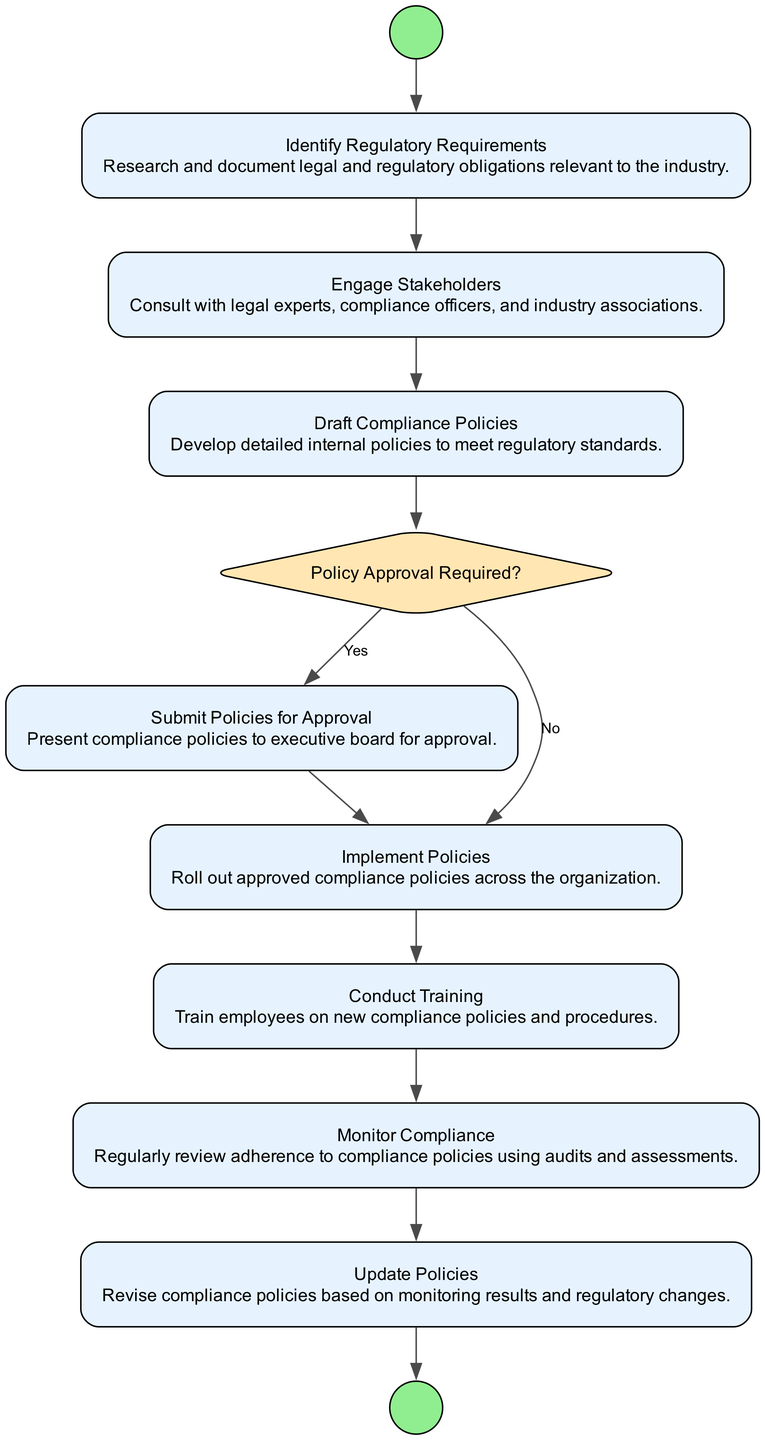What is the first activity in the diagram? The first activity in the diagram is "Identify Regulatory Requirements", which follows the "Initiate Compliance Policy Development" start event.
Answer: Identify Regulatory Requirements How many decision nodes are present in the diagram? There is one decision node labeled "Policy Approval Required?" in the diagram, indicating whether approval is needed or not.
Answer: 1 What comes after "Engage Stakeholders"? The activity that comes after "Engage Stakeholders" is "Draft Compliance Policies". This follows consecutively in the flow of the diagram.
Answer: Draft Compliance Policies What happens if the answer to "Policy Approval Required?" is "No"? If the answer is "No", the flow continues directly to the "Implement Policies" activity without needing to submit for approval.
Answer: Implement Policies What is the final event in the diagram? The final event in the diagram is "Compliance Policies Up to Date", indicating the process completion.
Answer: Compliance Policies Up to Date Which activity requires consulting with legal experts? The activity that requires consulting with legal experts is "Engage Stakeholders", as it involves discussions with various compliance associates.
Answer: Engage Stakeholders What is the purpose of "Monitor Compliance"? The purpose of "Monitor Compliance" is to regularly review adherence to compliance policies through audits and assessments.
Answer: Regular review What activity must be done before "Conduct Training"? Before "Conduct Training," the activity "Implement Policies" must be completed, ensuring policies are in place for training purposes.
Answer: Implement Policies How does the diagram illustrate the flow from policy drafting to implementation? The diagram shows that after "Draft Compliance Policies," there is a decision node to determine if policy approval is required; if not, it flows directly to implementation.
Answer: Decision node flow What leads to updating the policies? "Monitor Compliance" leads to "Update Policies," as the monitoring results inform the need for revisions to the compliance policies.
Answer: Monitor Compliance 